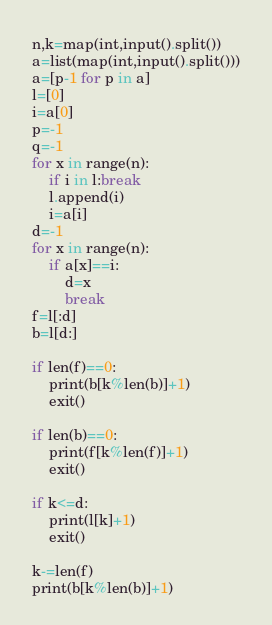Convert code to text. <code><loc_0><loc_0><loc_500><loc_500><_Python_>n,k=map(int,input().split())
a=list(map(int,input().split()))
a=[p-1 for p in a]
l=[0]
i=a[0]
p=-1
q=-1
for x in range(n):
    if i in l:break
    l.append(i)
    i=a[i]
d=-1
for x in range(n):
    if a[x]==i:
        d=x
        break
f=l[:d]
b=l[d:]

if len(f)==0:
    print(b[k%len(b)]+1)
    exit()

if len(b)==0:
    print(f[k%len(f)]+1)
    exit()

if k<=d:
    print(l[k]+1)
    exit()

k-=len(f)
print(b[k%len(b)]+1)</code> 